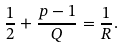Convert formula to latex. <formula><loc_0><loc_0><loc_500><loc_500>\frac { 1 } { 2 } + \frac { p - 1 } { Q } = \frac { 1 } { R } .</formula> 